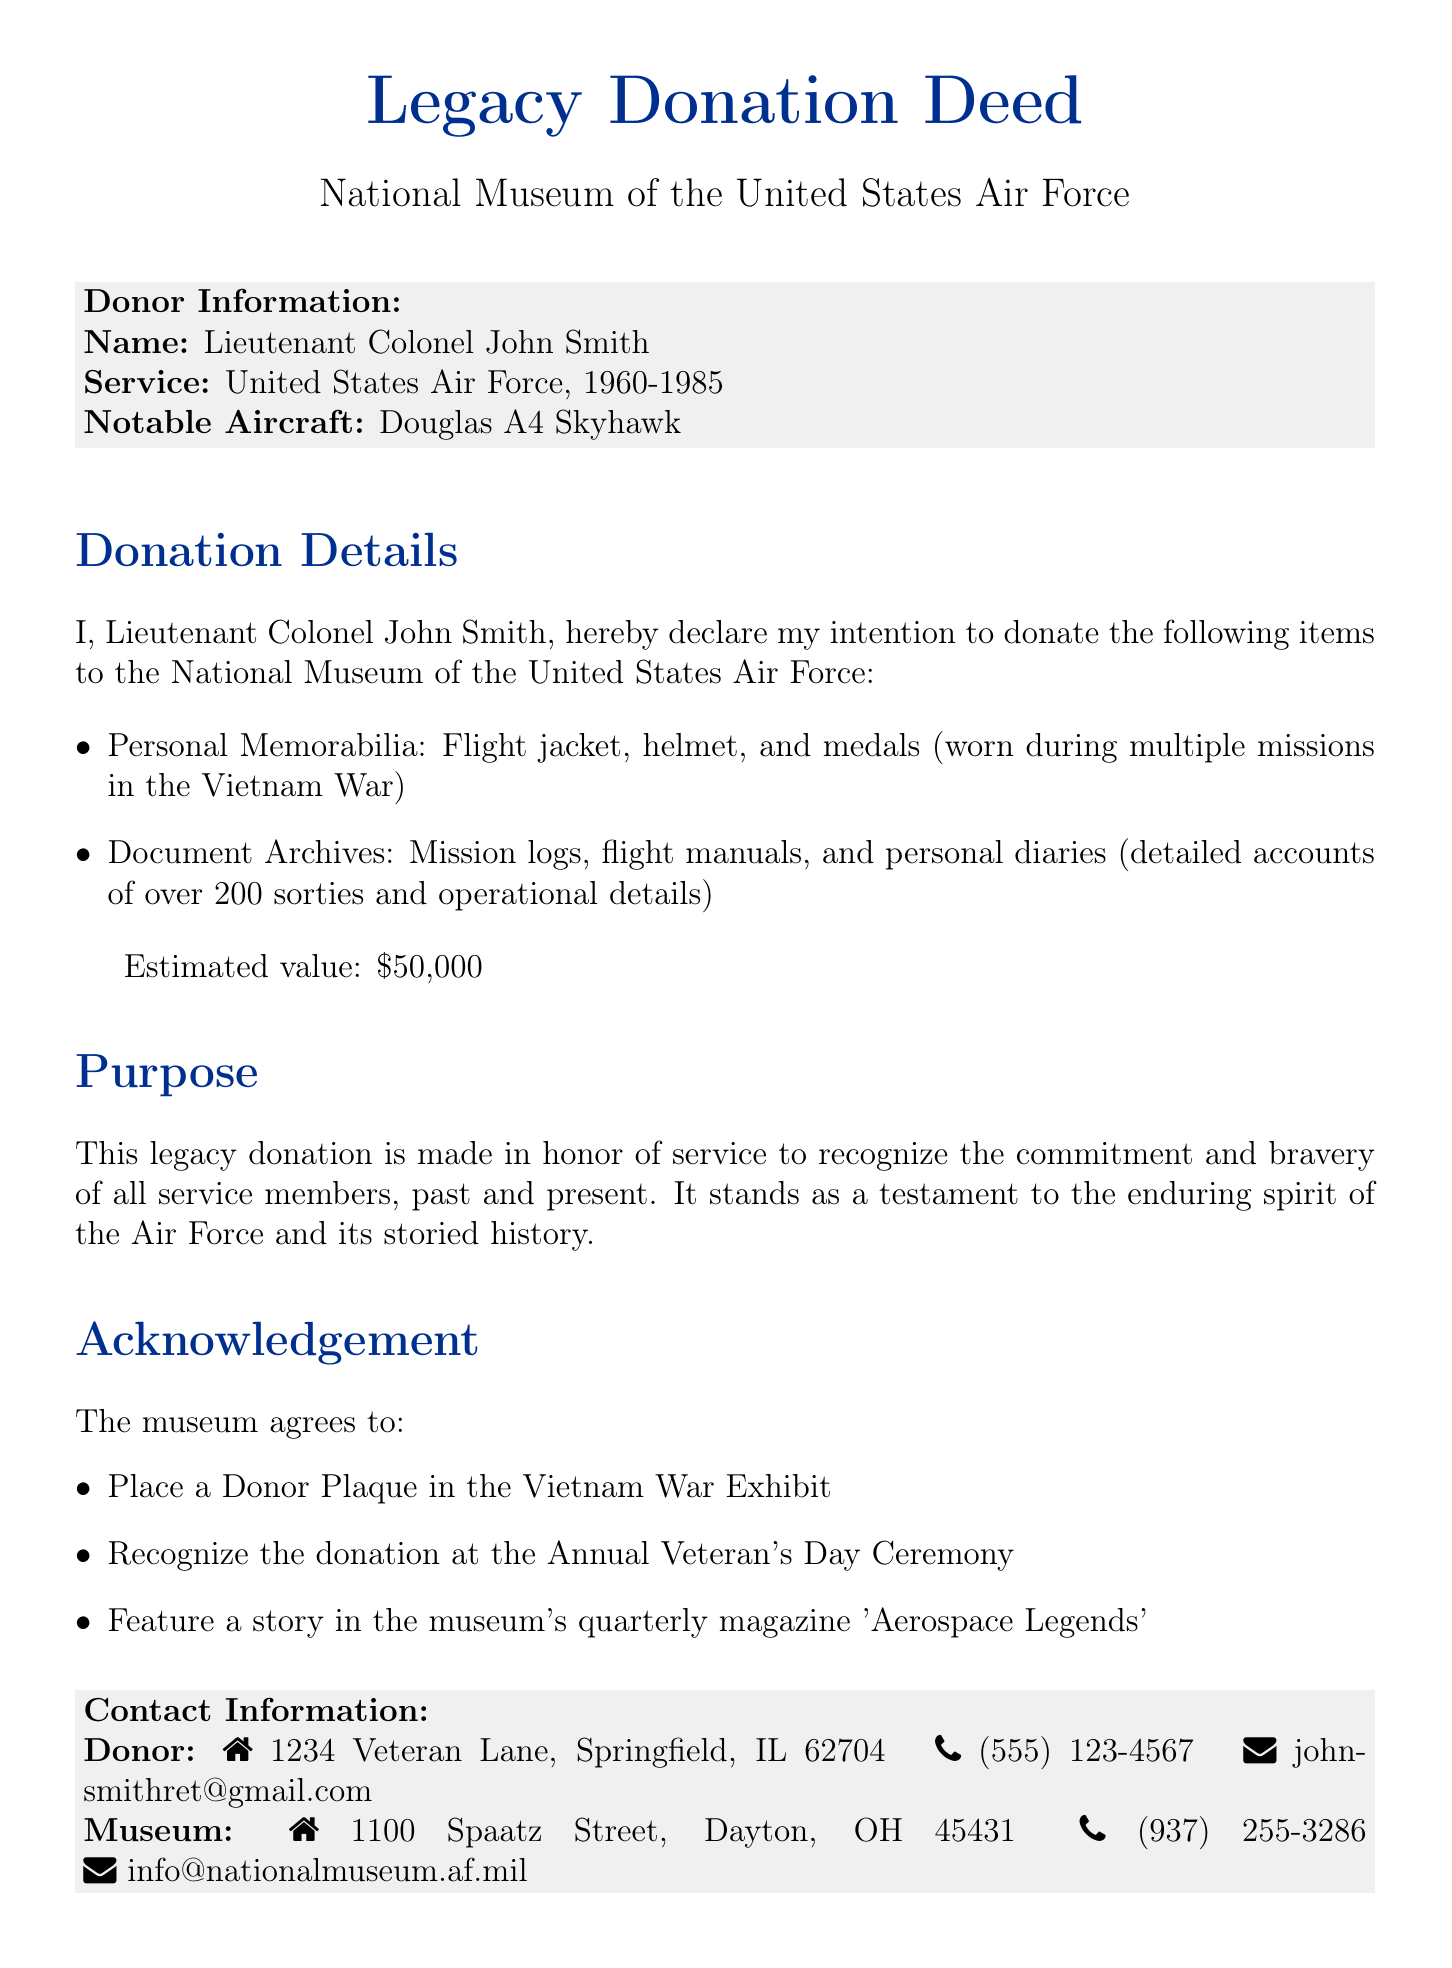What is the name of the donor? The document clearly states the donor's name at the beginning, which is Lieutenant Colonel John Smith.
Answer: Lieutenant Colonel John Smith What are the notable items included in the donation? The document lists personal memorabilia and document archives as part of the donation items.
Answer: Flight jacket, helmet, and medals; mission logs, flight manuals, and personal diaries What is the estimated value of the donation? The estimated value of the donation is provided in a specific monetary amount within the document.
Answer: $50,000 In honor of whom is the donation made? The document explicitly states that the donation is made in honor of service.
Answer: Service members What will the museum do in acknowledgment of the donation? The details of the museum's recognition actions are listed in bullet points under 'Acknowledgment'.
Answer: Place a Donor Plaque, recognize at the ceremony, feature in magazine What is the name of the museum representative? The document provides the name of the museum representative as part of the signature section.
Answer: Col. Michael Thompson What is the contact email of the donor? The specific email address for contacting the donor is given under donor contact information.
Answer: johnsmithret@gmail.com Where is the museum located? The document includes the address of the museum that can be found in the contact information section.
Answer: 1100 Spaatz Street, Dayton, OH 45431 